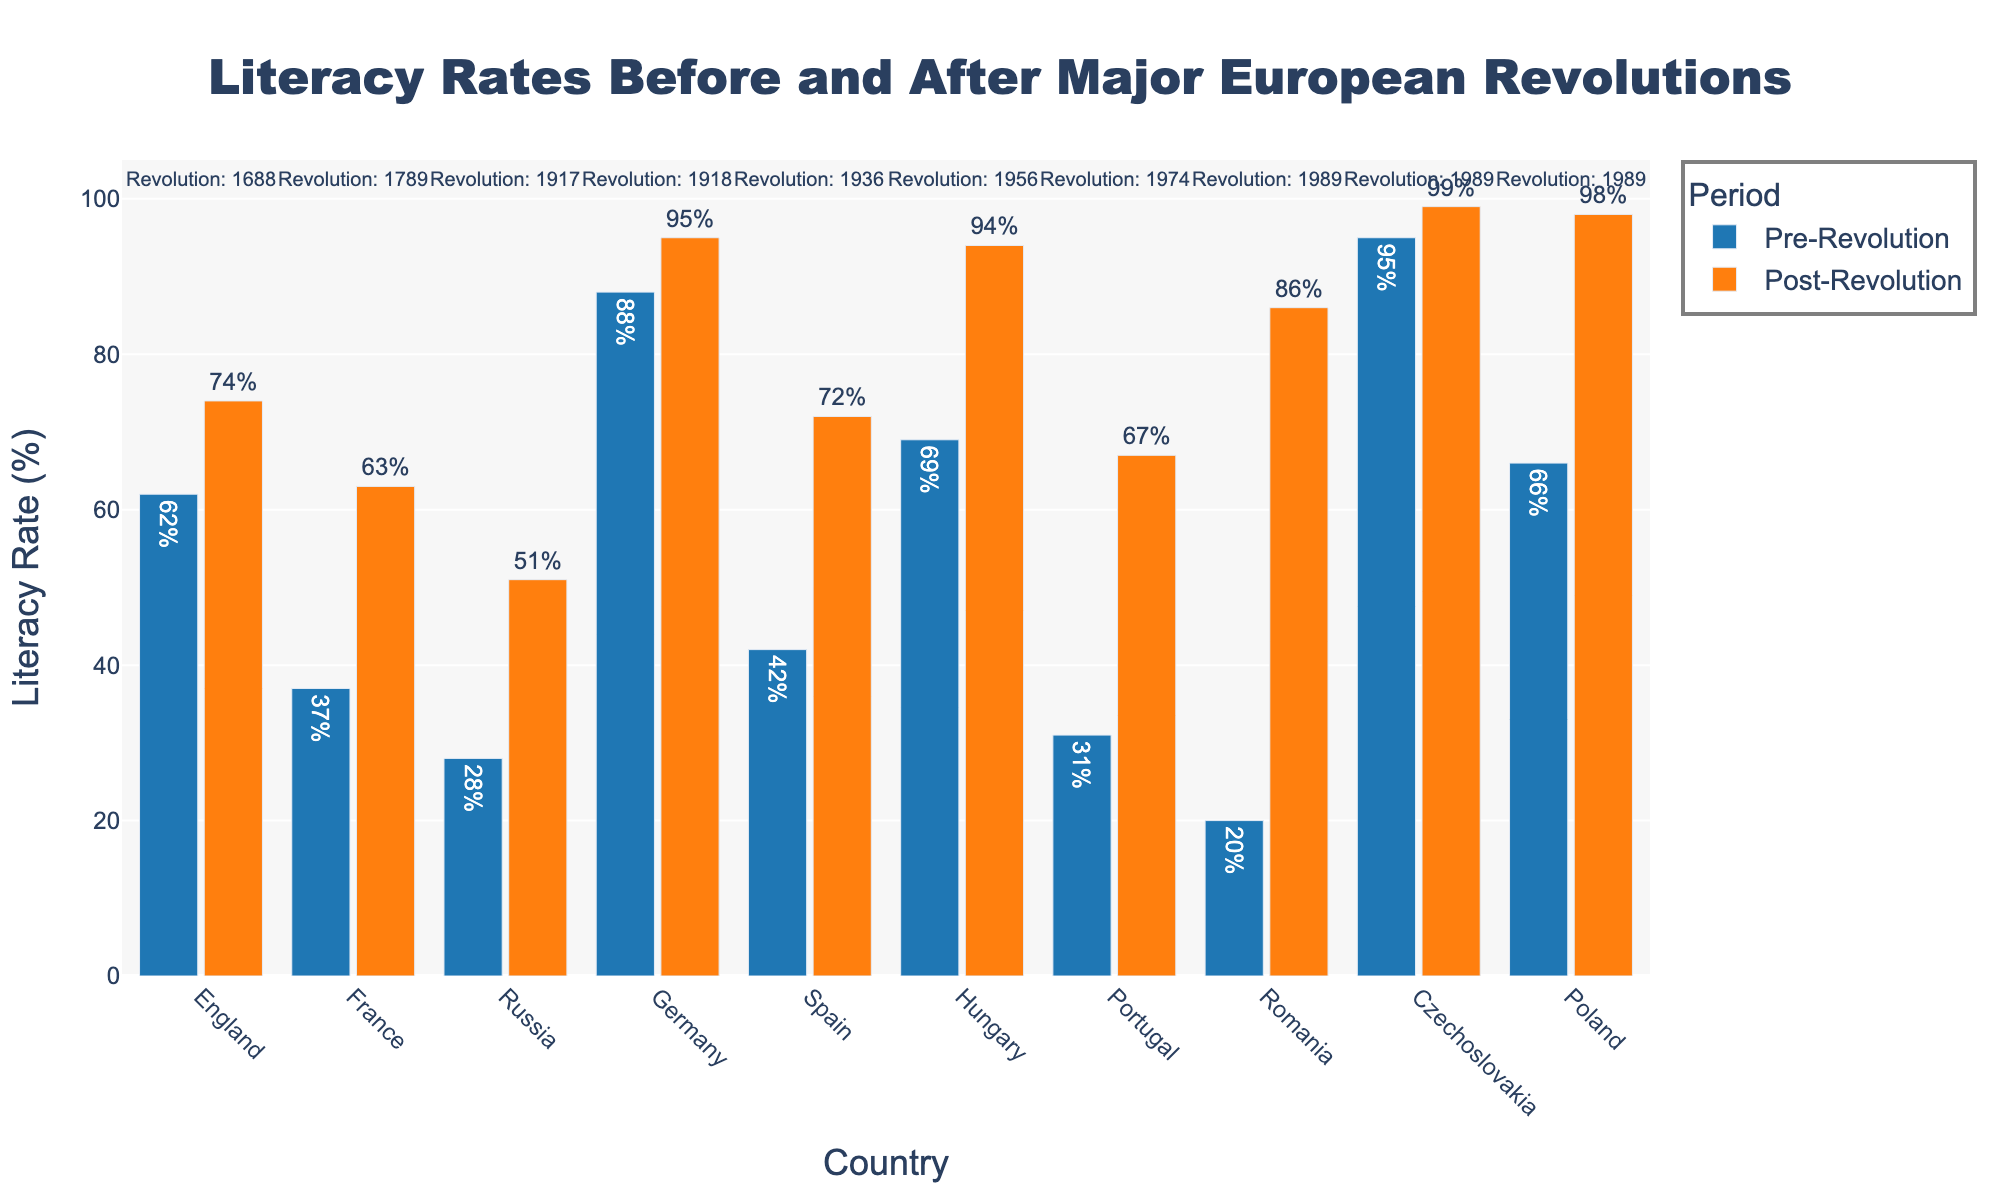What country experienced the highest increase in literacy rates after their revolution? First, calculate the difference between the post-revolution and pre-revolution literacy rates for each country. For Romania, the difference is 86% - 20% = 66%, which is the highest in the dataset.
Answer: Romania Which countries had a pre-revolution literacy rate greater than 60%? Compare the pre-revolution literacy rates of all countries to 60%. England (62%), Germany (88%), Hungary (69%), Czechoslovakia (95%), and Poland (66%) had pre-revolution literacy rates greater than 60%.
Answer: England, Germany, Hungary, Czechoslovakia, Poland What is the overall average post-revolution literacy rate? Sum the post-revolution literacy rates and divide by the total number of countries: (63 + 51 + 74 + 95 + 72 + 67 + 86 + 94 + 99 + 98) / 10 = 79.9%.
Answer: 79.9% Which country had its revolution the earliest? From the annotations on the figure, France had its revolution in 1789, which is the earliest among the listed countries.
Answer: France Which country had the smallest difference between pre-revolution and post-revolution literacy rates? Calculate the difference for all countries and find the smallest. For Czechoslovakia, the difference is 99% - 95% = 4%, which is the smallest.
Answer: Czechoslovakia How did the literacy rate in Germany change after the revolution? Look at the heights of the bars for Germany. The pre-revolution rate was 88% and the post-revolution rate was 95%.
Answer: Increased by 7% Which countries had a post-revolution literacy rate of at least 90%? Identify the countries where the post-revolution literacy rate is 90% or more. Germany (95%), Hungary (94%), Czechoslovakia (99%), and Poland (98%) meet this criterion.
Answer: Germany, Hungary, Czechoslovakia, Poland What is the difference in the increase of literacy rates between France and Russia? Calculate the increase for both countries, then find the difference. France: (63% - 37% = 26%), Russia: (51% - 28% = 23%), so the difference is 26% - 23% = 3%.
Answer: 3% Which country had the highest literacy rate before its revolution? Look at the heights of the bars for pre-revolution literacy rates. Czechoslovakia had the highest at 95%.
Answer: Czechoslovakia For countries with revolutions in the 20th century, what is the average pre-revolution literacy rate? Identify the countries with 20th-century revolutions and calculate the average pre-revolution literacy rate. Russia (28%), Germany (88%), Spain (42%), Portugal (31%), Romania (20%), Hungary (69%), Czechoslovakia (95%), Poland (66%). The average is (28 + 88 + 42 + 31 + 20 + 69 + 95 + 66) / 8 = 54.875%.
Answer: 54.875% 